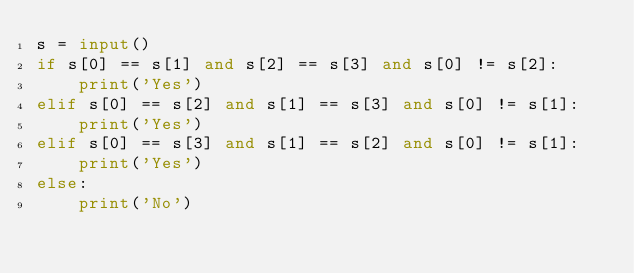Convert code to text. <code><loc_0><loc_0><loc_500><loc_500><_Python_>s = input()
if s[0] == s[1] and s[2] == s[3] and s[0] != s[2]:
    print('Yes')
elif s[0] == s[2] and s[1] == s[3] and s[0] != s[1]:
    print('Yes')
elif s[0] == s[3] and s[1] == s[2] and s[0] != s[1]:
    print('Yes')
else:
    print('No')</code> 